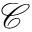<formula> <loc_0><loc_0><loc_500><loc_500>{ \ m a t h s c r C }</formula> 